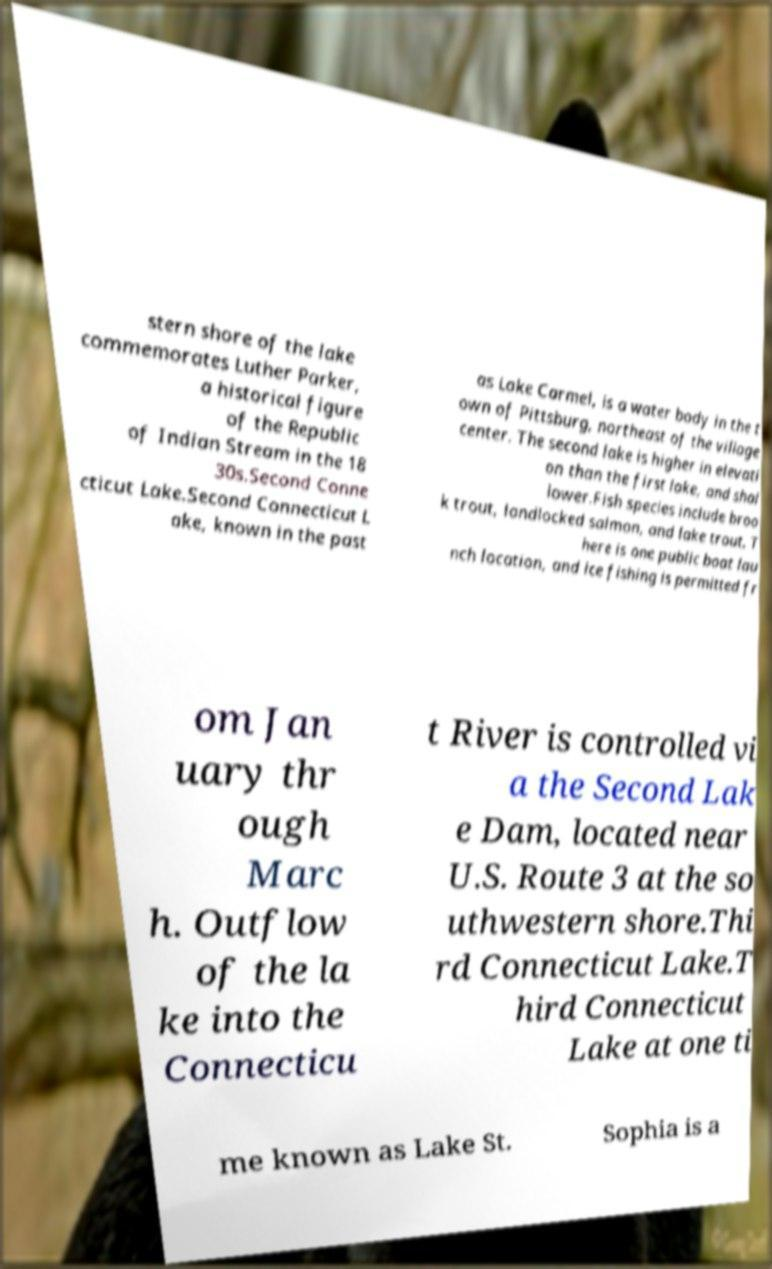There's text embedded in this image that I need extracted. Can you transcribe it verbatim? stern shore of the lake commemorates Luther Parker, a historical figure of the Republic of Indian Stream in the 18 30s.Second Conne cticut Lake.Second Connecticut L ake, known in the past as Lake Carmel, is a water body in the t own of Pittsburg, northeast of the village center. The second lake is higher in elevati on than the first lake, and shal lower.Fish species include broo k trout, landlocked salmon, and lake trout. T here is one public boat lau nch location, and ice fishing is permitted fr om Jan uary thr ough Marc h. Outflow of the la ke into the Connecticu t River is controlled vi a the Second Lak e Dam, located near U.S. Route 3 at the so uthwestern shore.Thi rd Connecticut Lake.T hird Connecticut Lake at one ti me known as Lake St. Sophia is a 